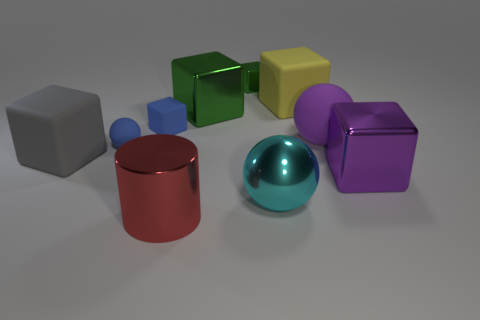Imagine these objects are part of a game; what could be the objective involving these items? In a game setting, these objects could be used for a sorting puzzle where you must arrange them according to size, color, or shape. Alternatively, they could be parts of a physics-based challenge where the objective is to balance them without toppling over, or a memory game where one must recall the position and attributes of each object after viewing them for a short period. 